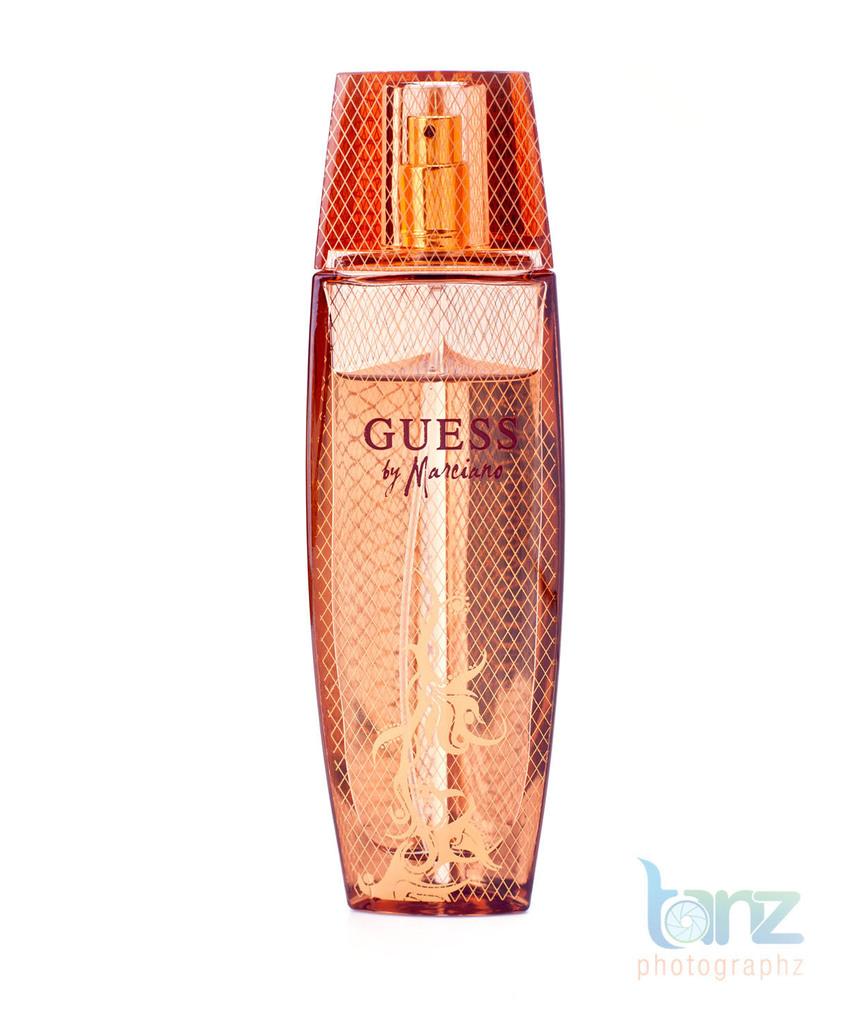What is the name of the photographer on the bottom?
Give a very brief answer. Tanz. 